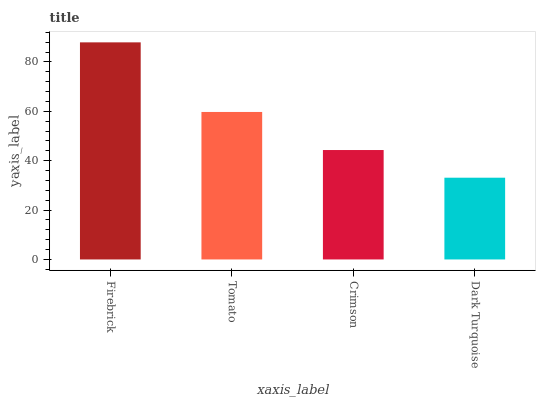Is Tomato the minimum?
Answer yes or no. No. Is Tomato the maximum?
Answer yes or no. No. Is Firebrick greater than Tomato?
Answer yes or no. Yes. Is Tomato less than Firebrick?
Answer yes or no. Yes. Is Tomato greater than Firebrick?
Answer yes or no. No. Is Firebrick less than Tomato?
Answer yes or no. No. Is Tomato the high median?
Answer yes or no. Yes. Is Crimson the low median?
Answer yes or no. Yes. Is Crimson the high median?
Answer yes or no. No. Is Tomato the low median?
Answer yes or no. No. 